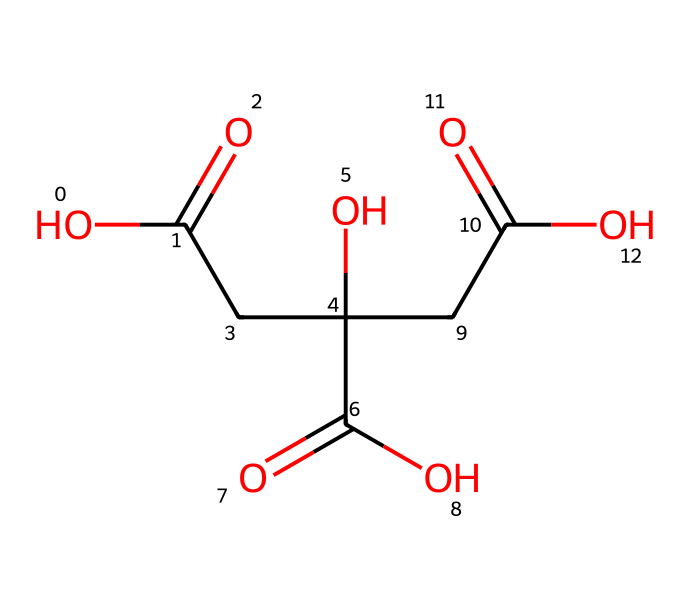What is the main functional group present in citric acid? The main functional group in citric acid is the carboxylic acid group, identifiable as -COOH in the structure. This indicates that citric acid has multiple acidic protons.
Answer: carboxylic acid How many carbon atoms are in citric acid? By analyzing the SMILES representation, we can count a total of six carbon atoms represented in the structure, as each "C" denotes a carbon.
Answer: six What type of acid is citric acid classified as? Citric acid is classified as a weak organic acid due to the presence of multiple carboxylic acid groups, which dissociate partially in solution.
Answer: weak organic acid How many hydroxyl (-OH) groups does citric acid contain? In the structure, there are three hydroxyl groups (-OH), indicated by the "O" connected to "C", revealing the presence of these functional groups.
Answer: three What is the pH characteristic of citric acid in solution? Citric acid has a pH characteristic of being acidic when dissolved in water, reflecting its nature as an acid that contributes to lower pH levels.
Answer: acidic What role does citric acid play in cleaning solutions for piano keys? Citric acid acts as a chelating agent and helps in breaking down mineral deposits, which makes it effective in cleaning solutions.
Answer: chelating agent 